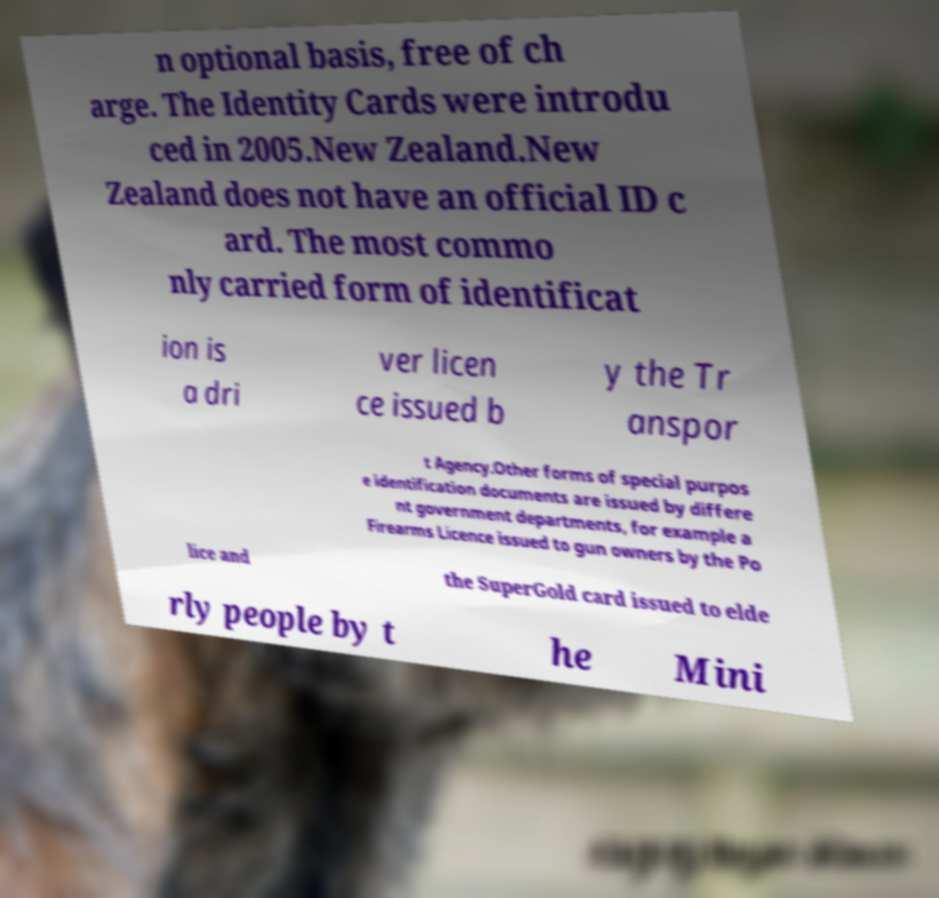What messages or text are displayed in this image? I need them in a readable, typed format. n optional basis, free of ch arge. The Identity Cards were introdu ced in 2005.New Zealand.New Zealand does not have an official ID c ard. The most commo nly carried form of identificat ion is a dri ver licen ce issued b y the Tr anspor t Agency.Other forms of special purpos e identification documents are issued by differe nt government departments, for example a Firearms Licence issued to gun owners by the Po lice and the SuperGold card issued to elde rly people by t he Mini 